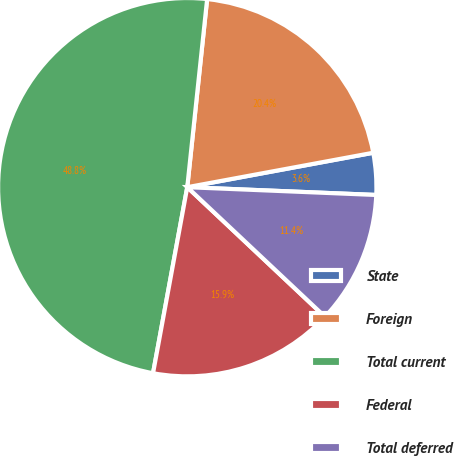Convert chart. <chart><loc_0><loc_0><loc_500><loc_500><pie_chart><fcel>State<fcel>Foreign<fcel>Total current<fcel>Federal<fcel>Total deferred<nl><fcel>3.57%<fcel>20.41%<fcel>48.78%<fcel>15.88%<fcel>11.36%<nl></chart> 